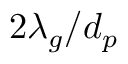<formula> <loc_0><loc_0><loc_500><loc_500>2 \lambda _ { g } / d _ { p }</formula> 